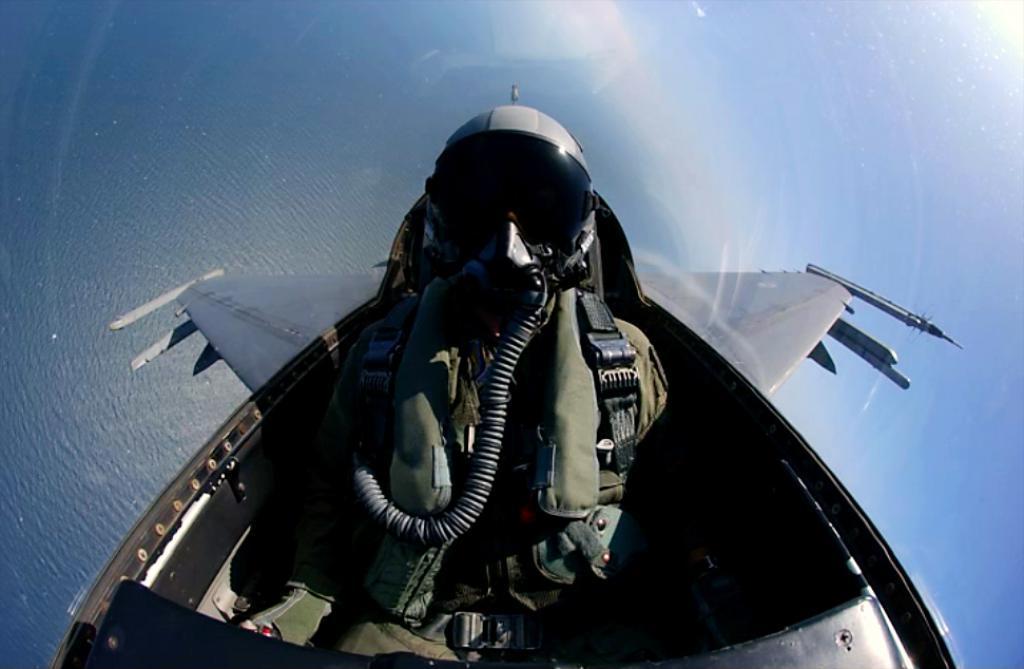Please provide a concise description of this image. In the center of the image we can see a man sitting in the plane. 